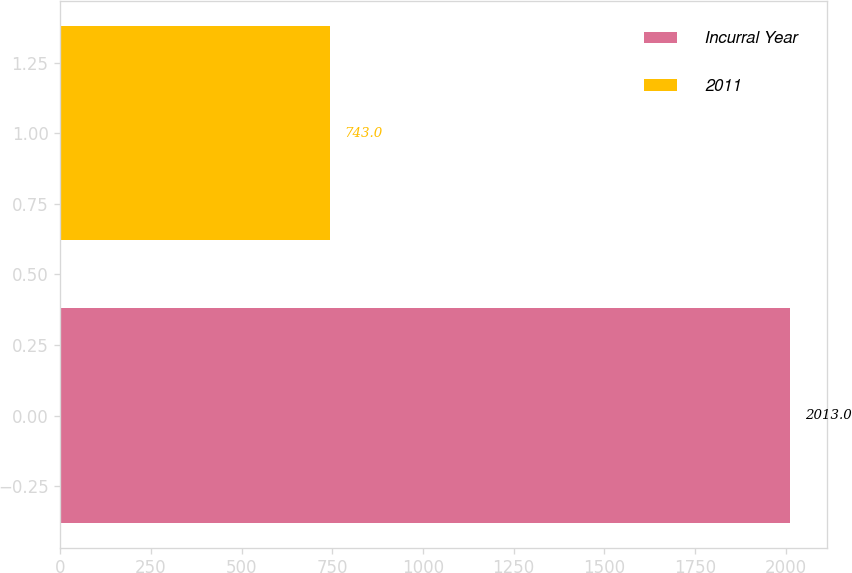Convert chart to OTSL. <chart><loc_0><loc_0><loc_500><loc_500><bar_chart><fcel>Incurral Year<fcel>2011<nl><fcel>2013<fcel>743<nl></chart> 